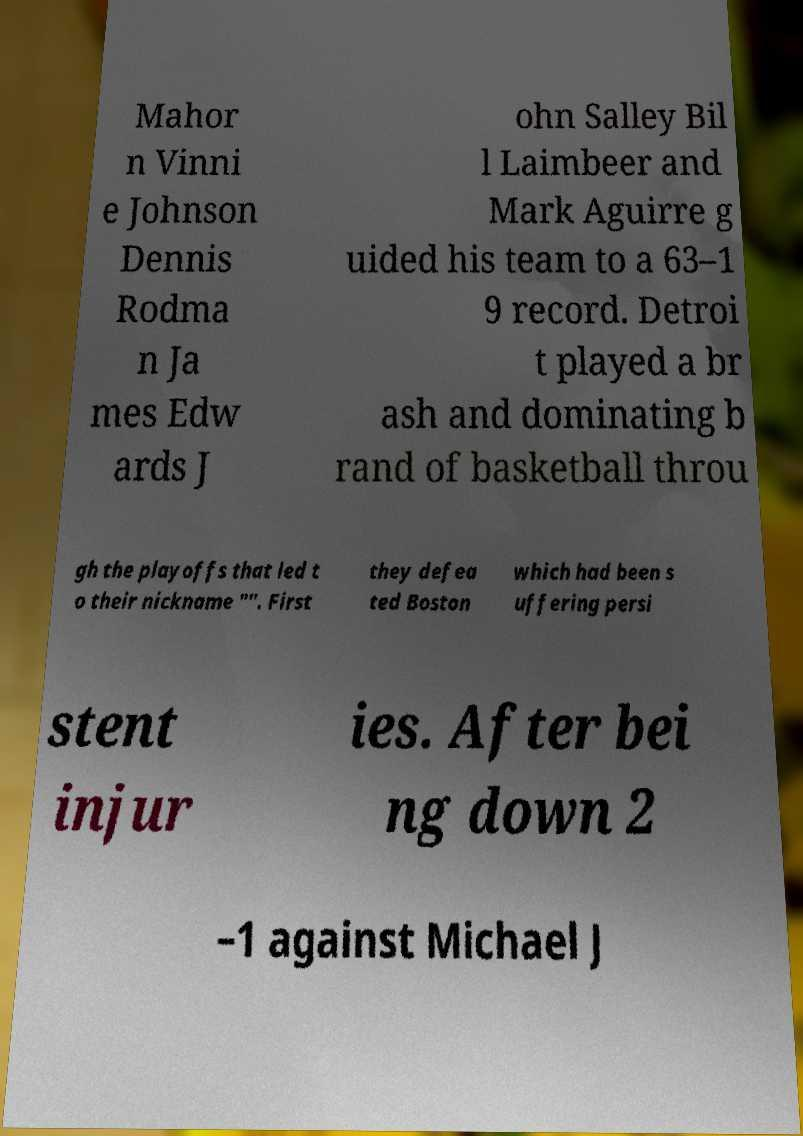Could you assist in decoding the text presented in this image and type it out clearly? Mahor n Vinni e Johnson Dennis Rodma n Ja mes Edw ards J ohn Salley Bil l Laimbeer and Mark Aguirre g uided his team to a 63–1 9 record. Detroi t played a br ash and dominating b rand of basketball throu gh the playoffs that led t o their nickname "". First they defea ted Boston which had been s uffering persi stent injur ies. After bei ng down 2 –1 against Michael J 